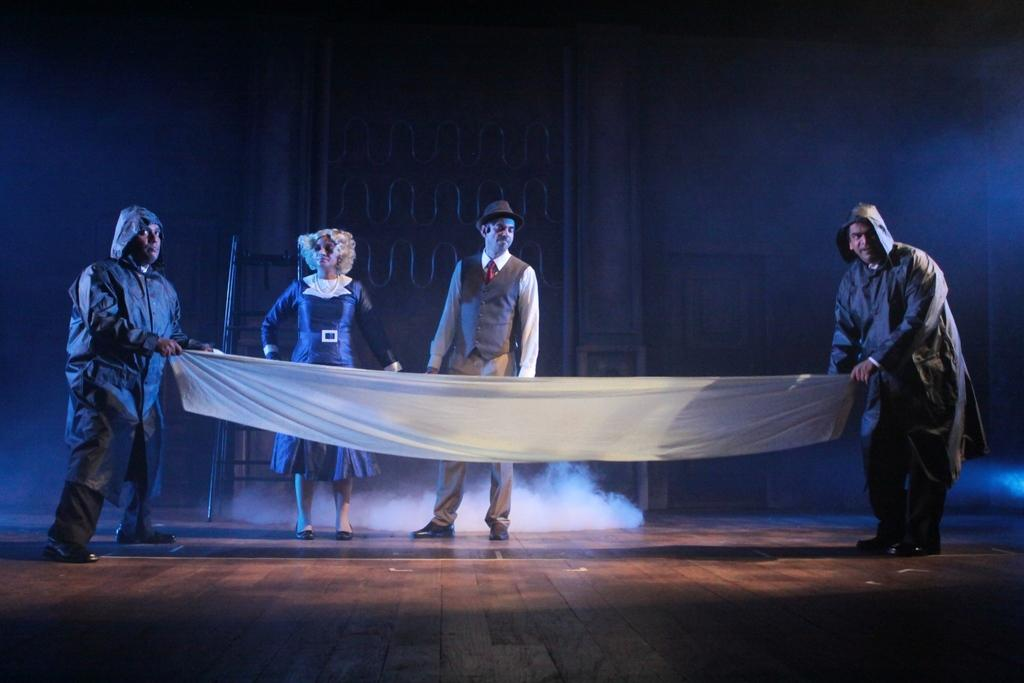How many people are present in the image? There are four persons standing in the image. What are the persons holding in the image? The persons are holding a cloth. Can you describe any objects in the image? Yes, there is an object in the image. What can be seen in the background of the image? There is a door and a wall in the background of the image. What type of horse can be seen in the image? There is no horse present in the image. What kind of meal are the persons sharing in the image? There is no meal visible in the image; the persons are holding a cloth. 